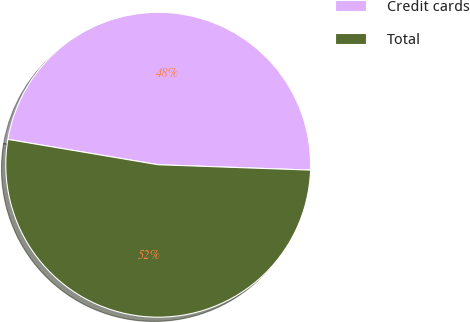Convert chart. <chart><loc_0><loc_0><loc_500><loc_500><pie_chart><fcel>Credit cards<fcel>Total<nl><fcel>47.9%<fcel>52.1%<nl></chart> 